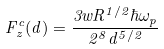Convert formula to latex. <formula><loc_0><loc_0><loc_500><loc_500>F ^ { c } _ { z } ( d ) = \frac { 3 w R ^ { 1 / 2 } \hbar { \omega } _ { p } } { 2 ^ { 8 } d ^ { 5 / 2 } }</formula> 